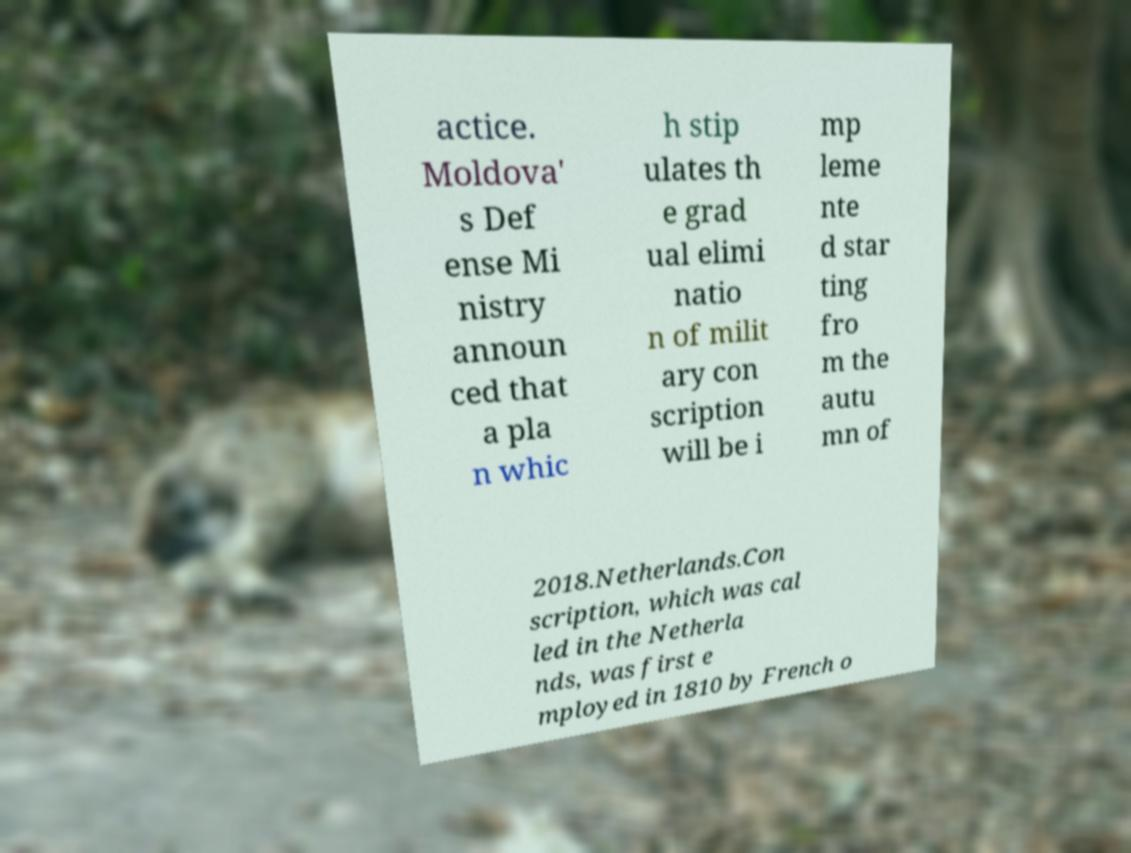Could you extract and type out the text from this image? actice. Moldova' s Def ense Mi nistry announ ced that a pla n whic h stip ulates th e grad ual elimi natio n of milit ary con scription will be i mp leme nte d star ting fro m the autu mn of 2018.Netherlands.Con scription, which was cal led in the Netherla nds, was first e mployed in 1810 by French o 